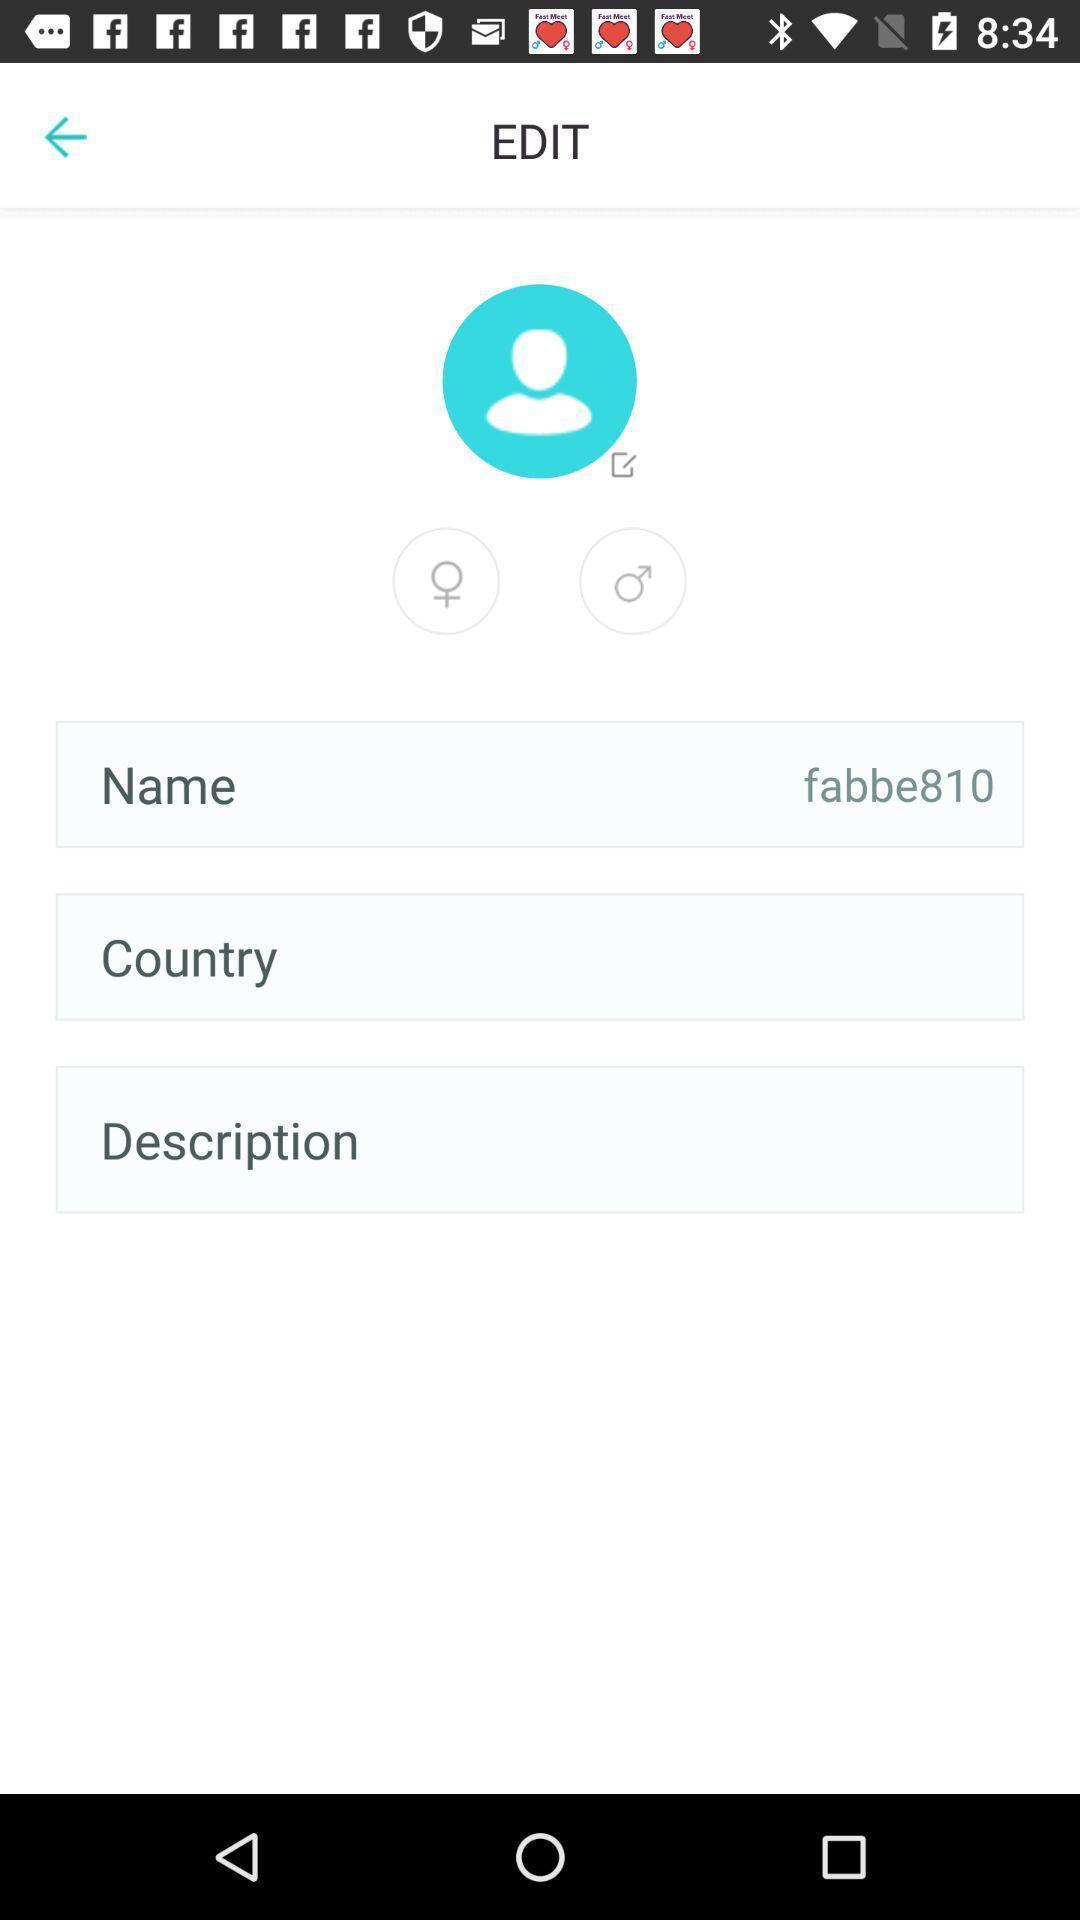Give me a narrative description of this picture. Page displaying to enter the details in a profile. 